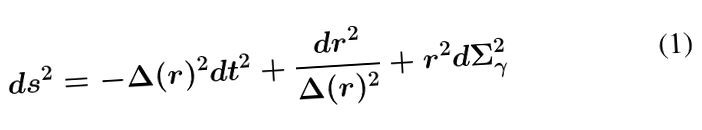Convert formula to latex. <formula><loc_0><loc_0><loc_500><loc_500>d s ^ { 2 } = - \Delta ( r ) ^ { 2 } d t ^ { 2 } + \frac { d r ^ { 2 } } { \Delta ( r ) ^ { 2 } } + r ^ { 2 } d \Sigma _ { \gamma } ^ { 2 }</formula> 